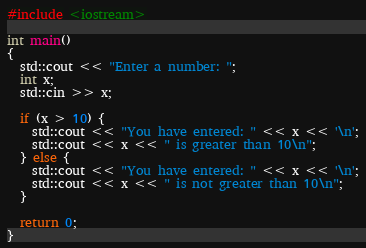Convert code to text. <code><loc_0><loc_0><loc_500><loc_500><_C++_>#include <iostream>

int main()
{
  std::cout << "Enter a number: ";
  int x;
  std::cin >> x;

  if (x > 10) {
    std::cout << "You have entered: " << x << '\n';
    std::cout << x << " is greater than 10\n";
  } else {
    std::cout << "You have entered: " << x << '\n';
    std::cout << x << " is not greater than 10\n";
  }

  return 0;
}
</code> 